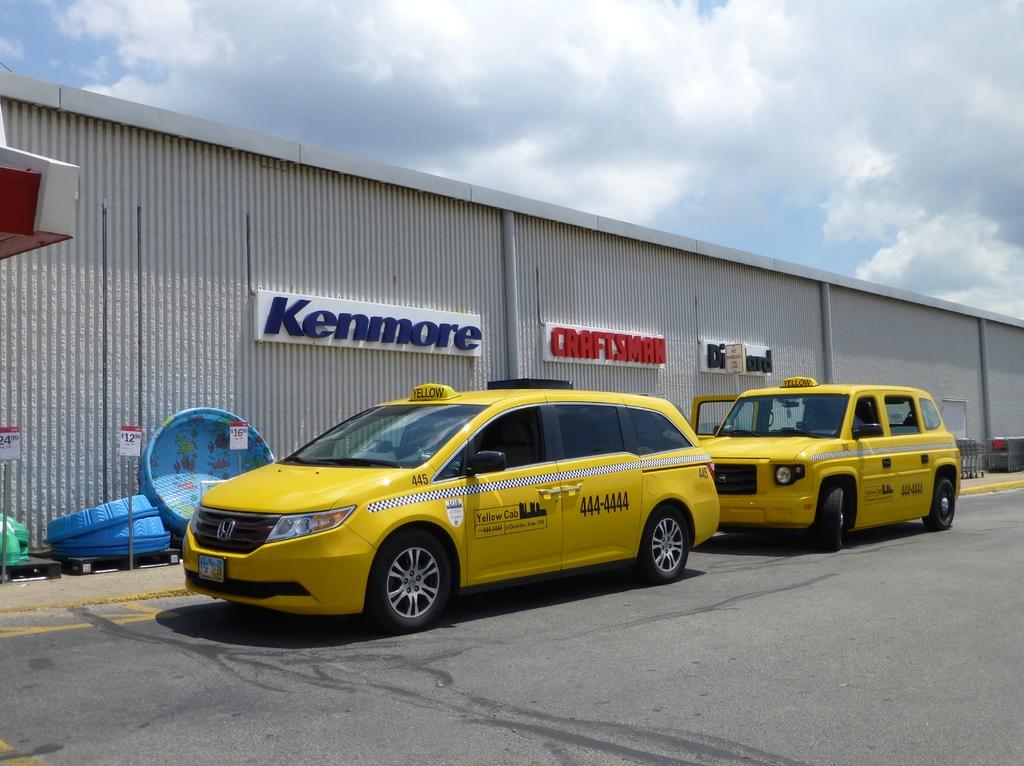What is the phone number for yellow cab?
Keep it short and to the point. 444-4444. What does the sign in blue say?
Provide a succinct answer. Kenmore. 